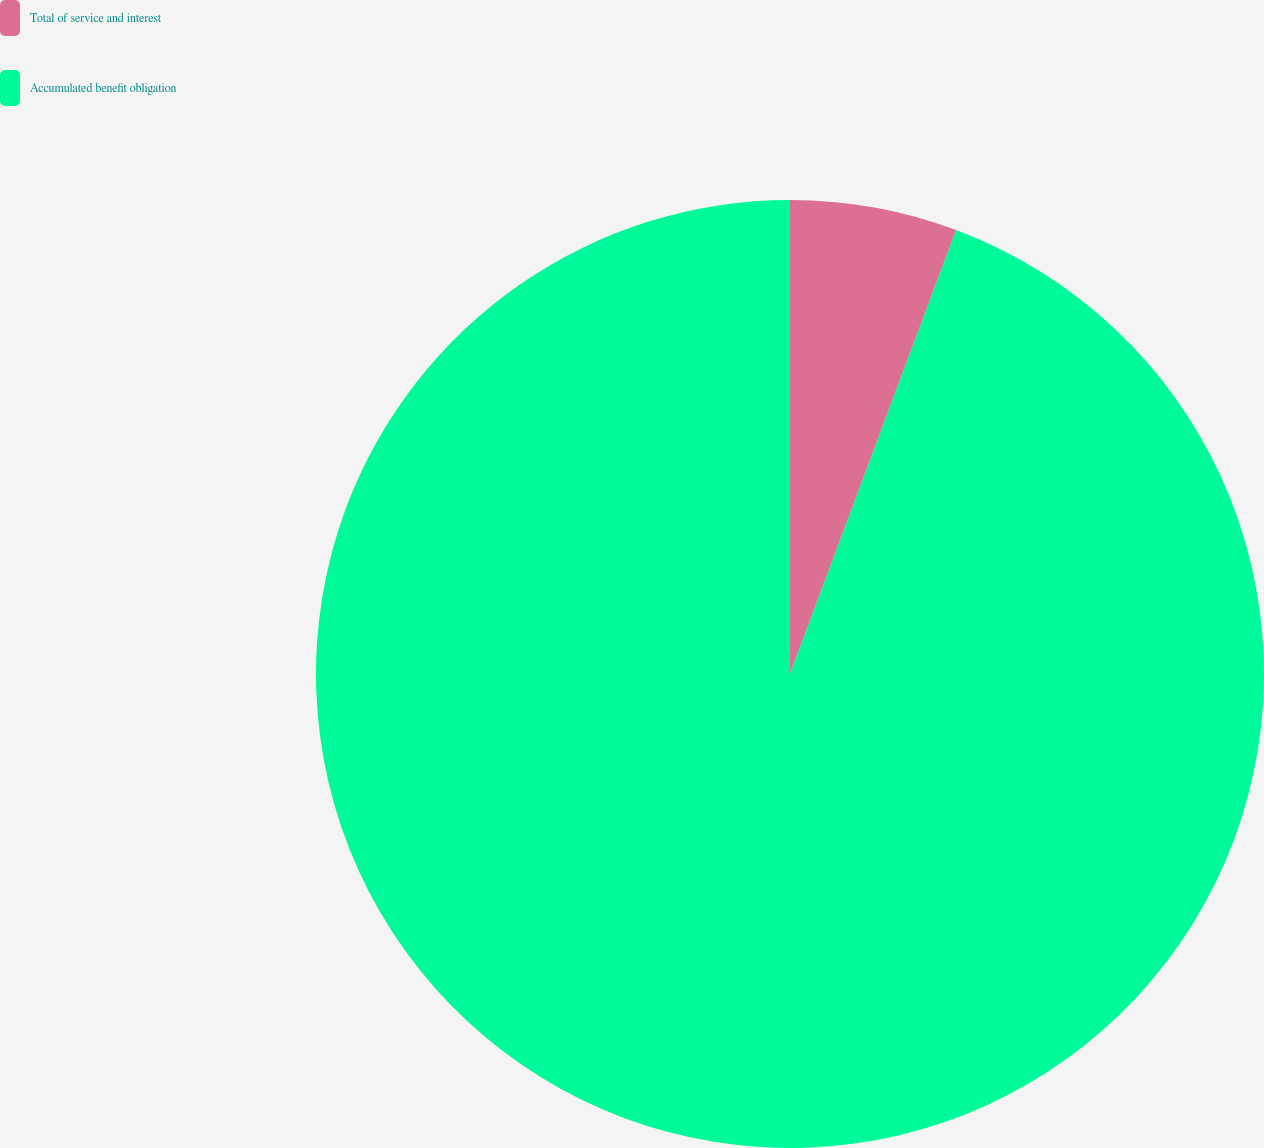Convert chart. <chart><loc_0><loc_0><loc_500><loc_500><pie_chart><fcel>Total of service and interest<fcel>Accumulated benefit obligation<nl><fcel>5.7%<fcel>94.3%<nl></chart> 